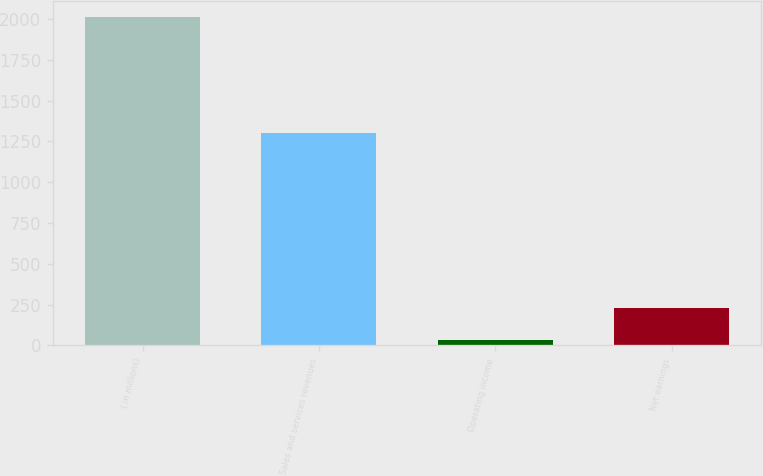Convert chart. <chart><loc_0><loc_0><loc_500><loc_500><bar_chart><fcel>( in millions)<fcel>Sales and services revenues<fcel>Operating income<fcel>Net earnings<nl><fcel>2009<fcel>1303<fcel>34<fcel>231.5<nl></chart> 